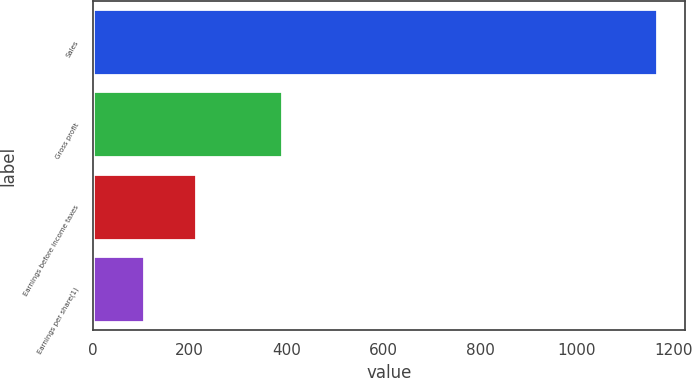Convert chart. <chart><loc_0><loc_0><loc_500><loc_500><bar_chart><fcel>Sales<fcel>Gross profit<fcel>Earnings before income taxes<fcel>Earnings per share(1)<nl><fcel>1165.9<fcel>389.6<fcel>212.26<fcel>106.3<nl></chart> 